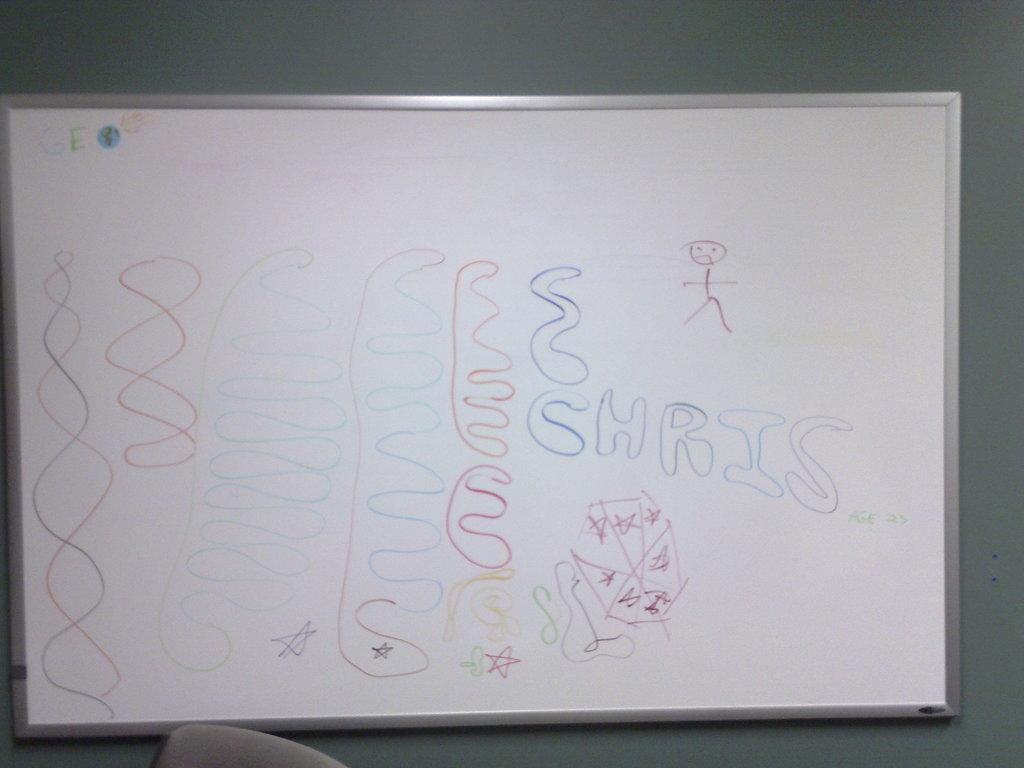What is the main object in the image? There is a white color board in the image. What is on the color board? There is writing on the board. Is there any furniture in the image? Yes, there is a chair in the image. How is the color board positioned in the image? The board is attached to a wall. What type of owl can be seen in the aftermath of the event in the image? There is no owl or event present in the image; it features a white color board with writing on it, attached to a wall. 